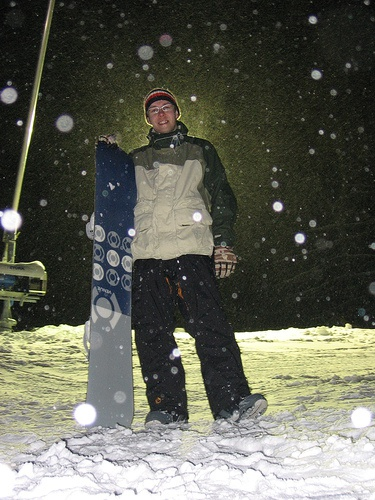Describe the objects in this image and their specific colors. I can see people in black, darkgray, and gray tones and snowboard in black, gray, and darkgray tones in this image. 